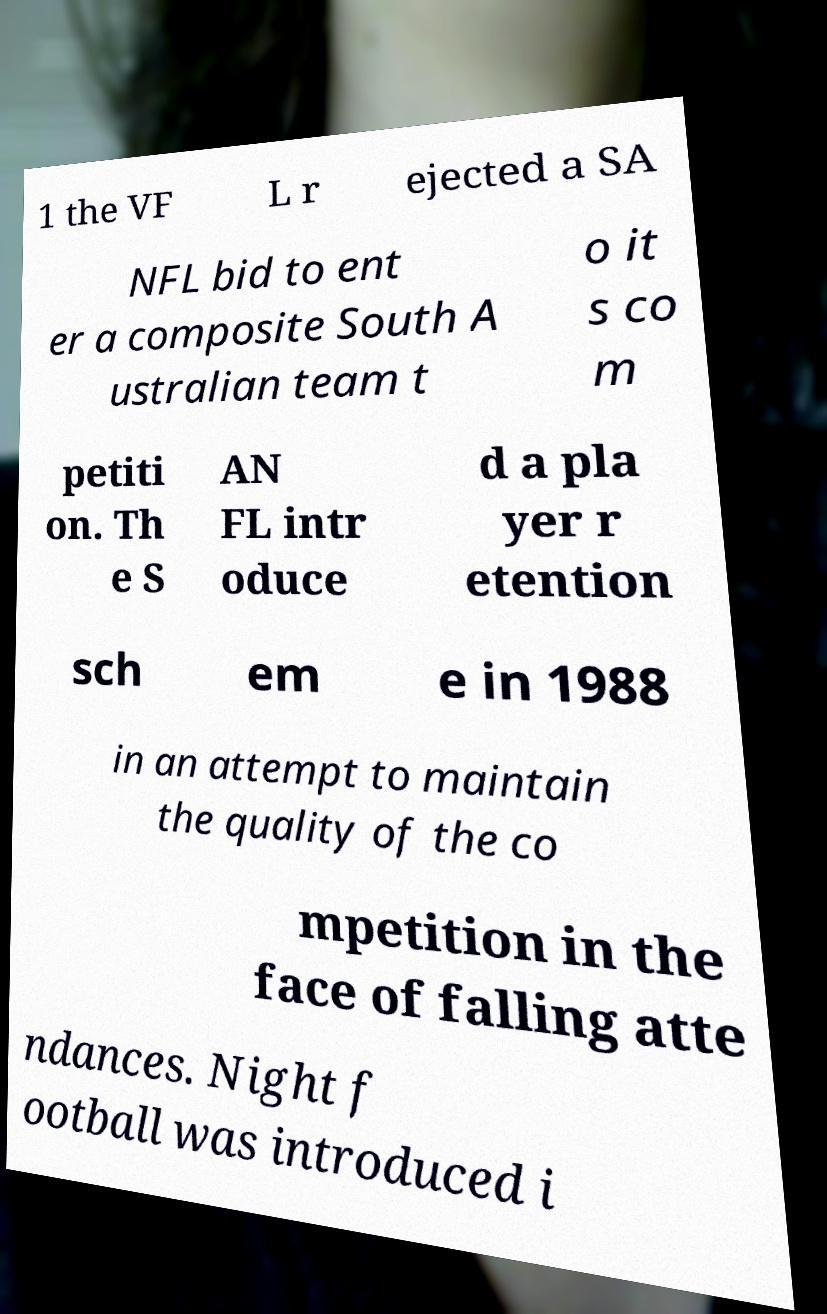Can you accurately transcribe the text from the provided image for me? 1 the VF L r ejected a SA NFL bid to ent er a composite South A ustralian team t o it s co m petiti on. Th e S AN FL intr oduce d a pla yer r etention sch em e in 1988 in an attempt to maintain the quality of the co mpetition in the face of falling atte ndances. Night f ootball was introduced i 